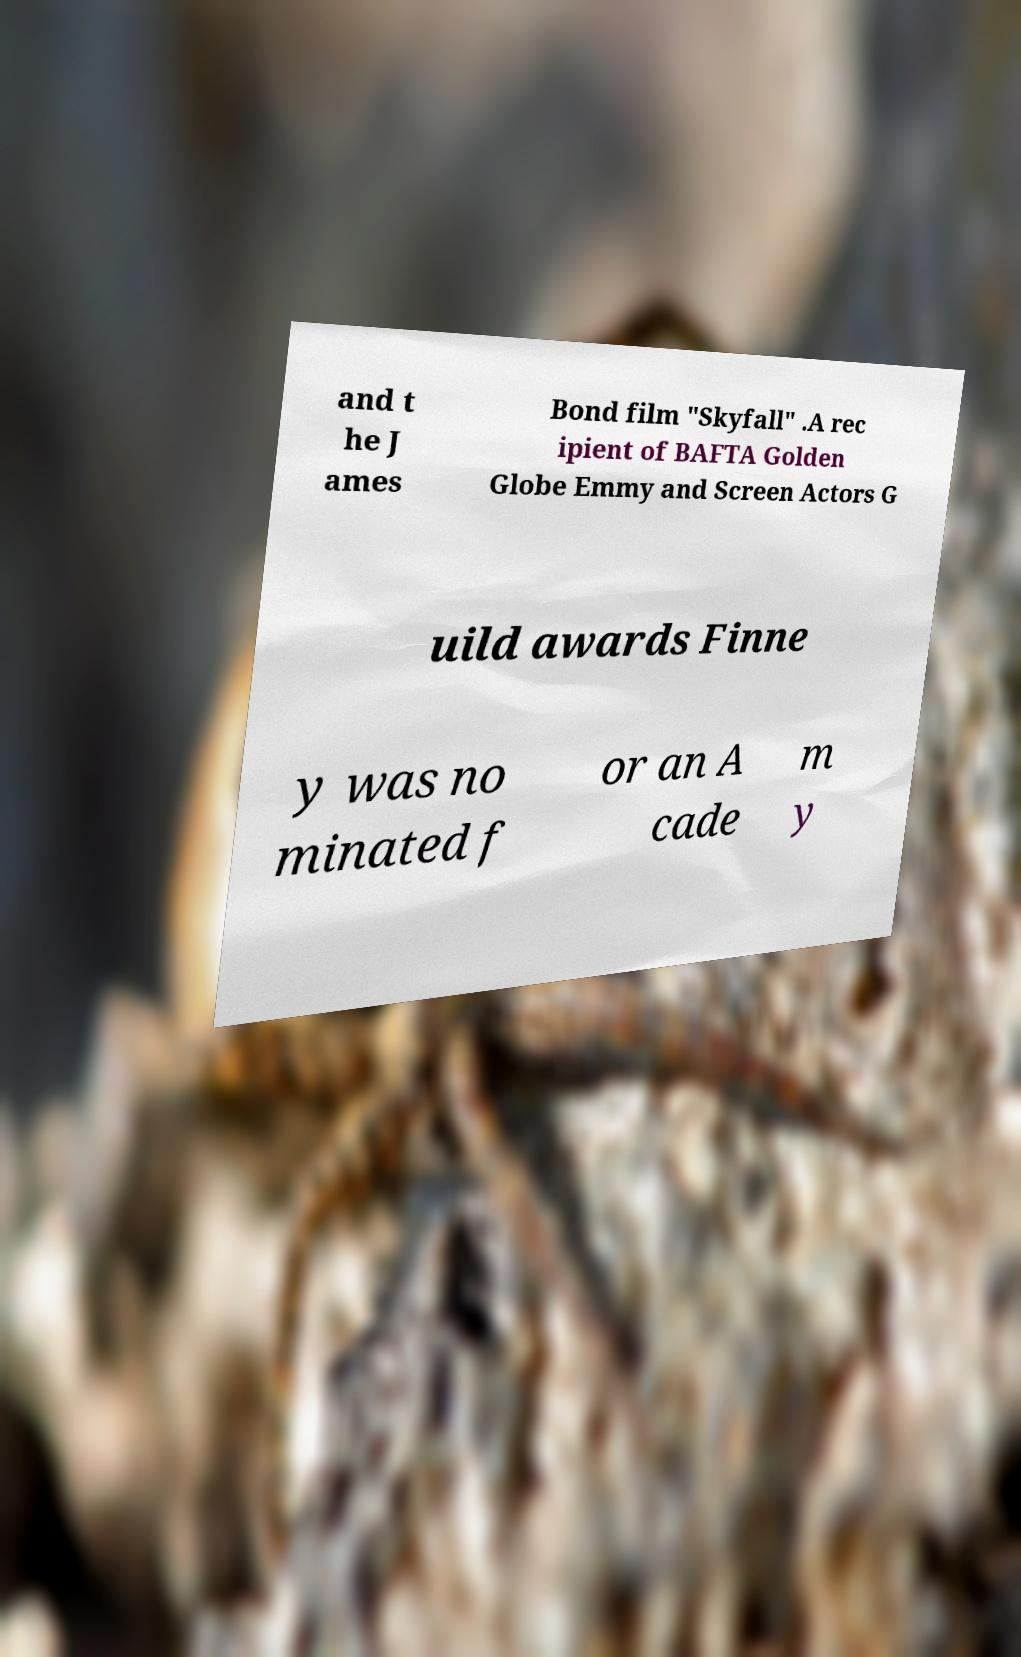Could you assist in decoding the text presented in this image and type it out clearly? and t he J ames Bond film "Skyfall" .A rec ipient of BAFTA Golden Globe Emmy and Screen Actors G uild awards Finne y was no minated f or an A cade m y 